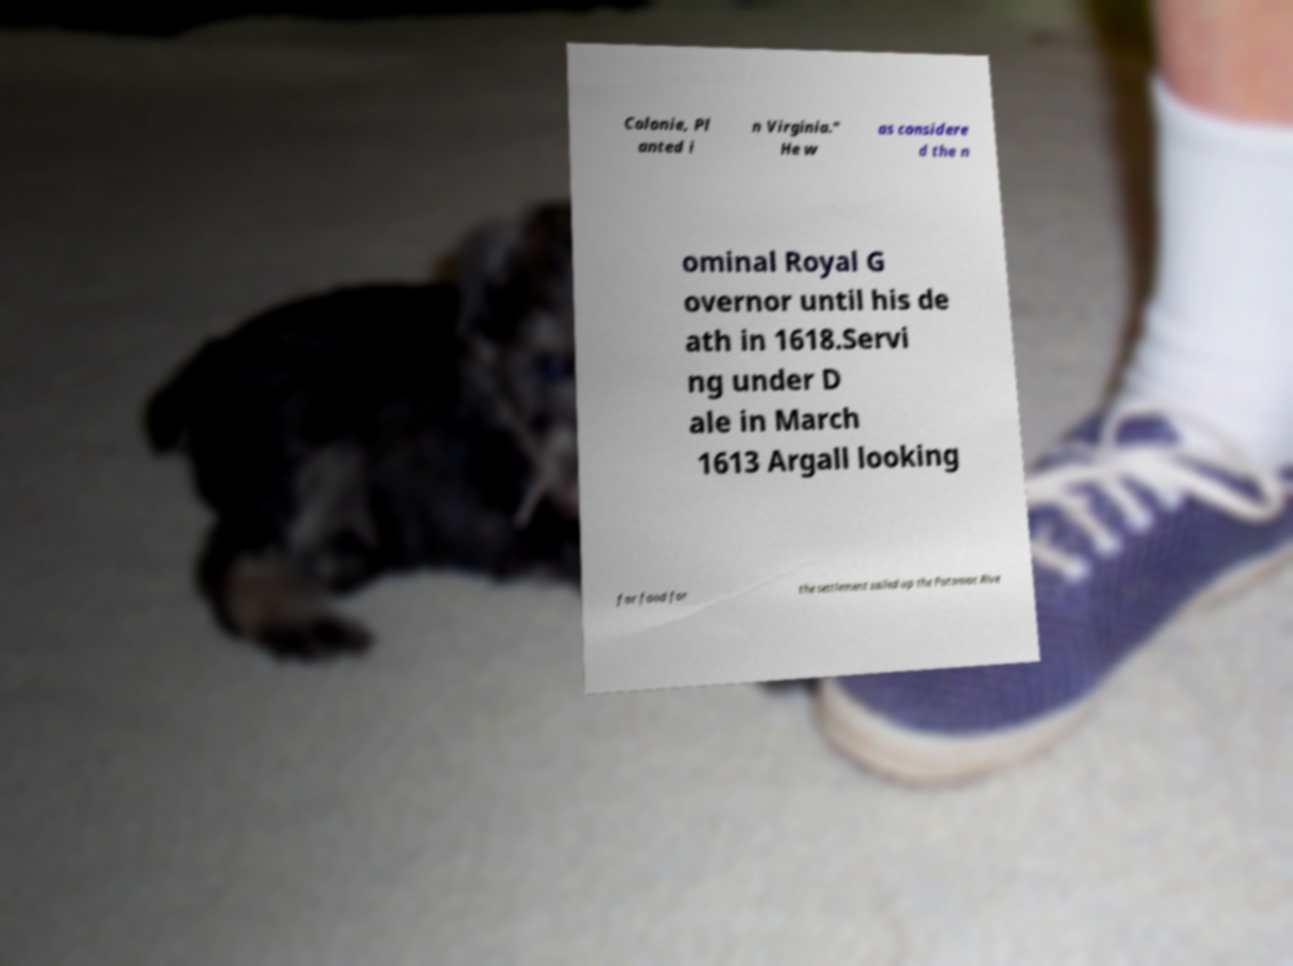Please read and relay the text visible in this image. What does it say? Colonie, Pl anted i n Virginia." He w as considere d the n ominal Royal G overnor until his de ath in 1618.Servi ng under D ale in March 1613 Argall looking for food for the settlement sailed up the Potomac Rive 